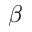Convert formula to latex. <formula><loc_0><loc_0><loc_500><loc_500>\beta</formula> 